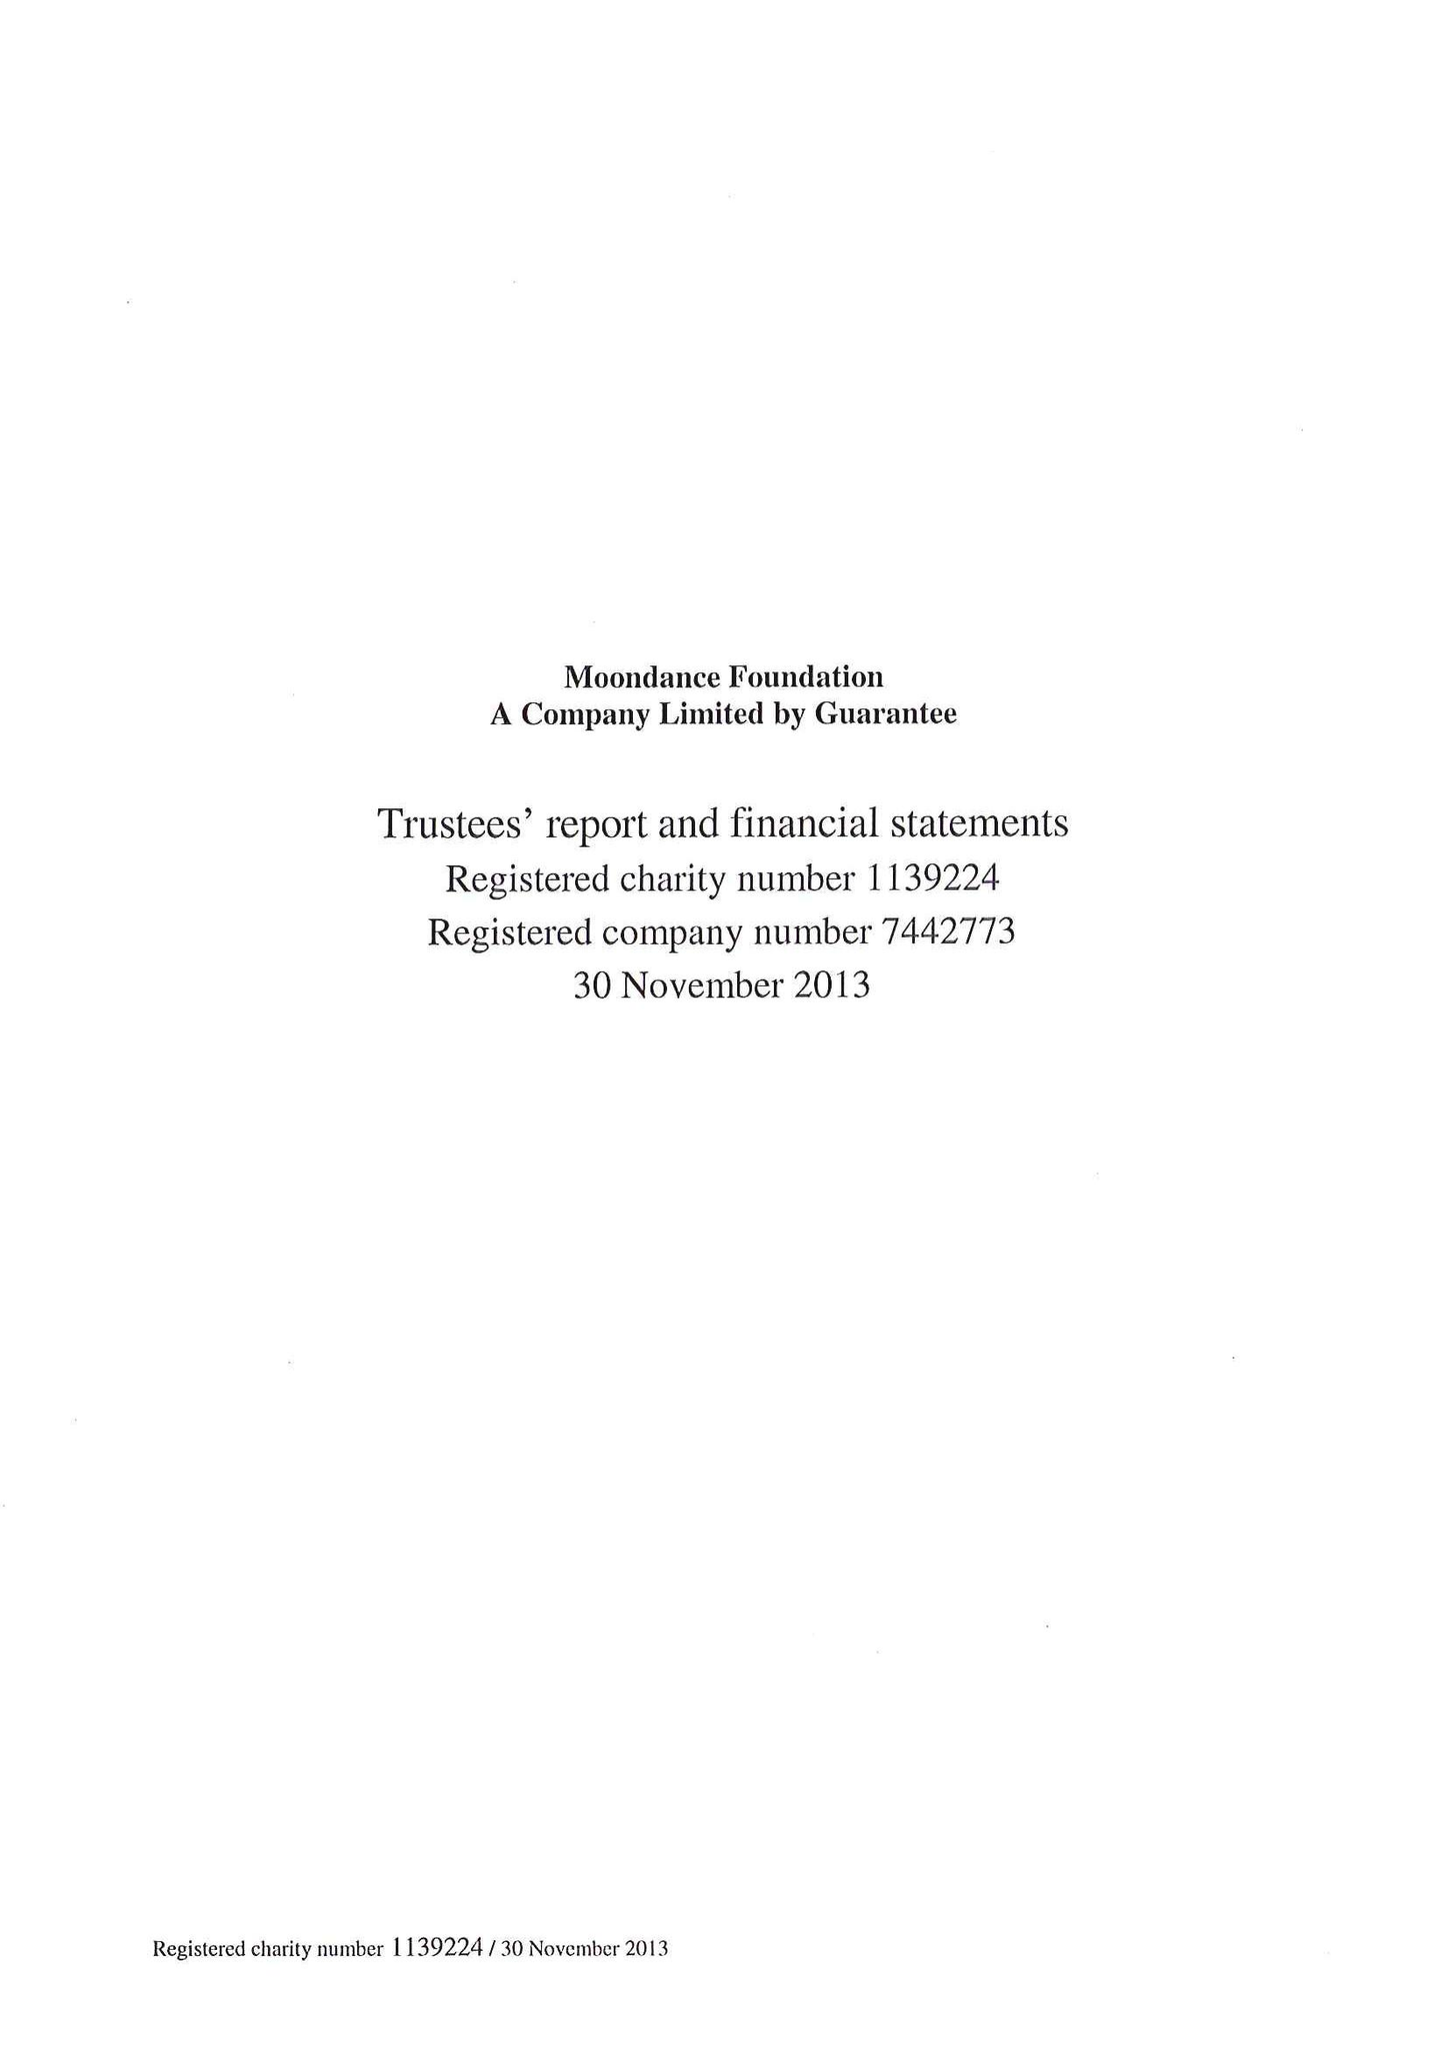What is the value for the charity_number?
Answer the question using a single word or phrase. 1139224 